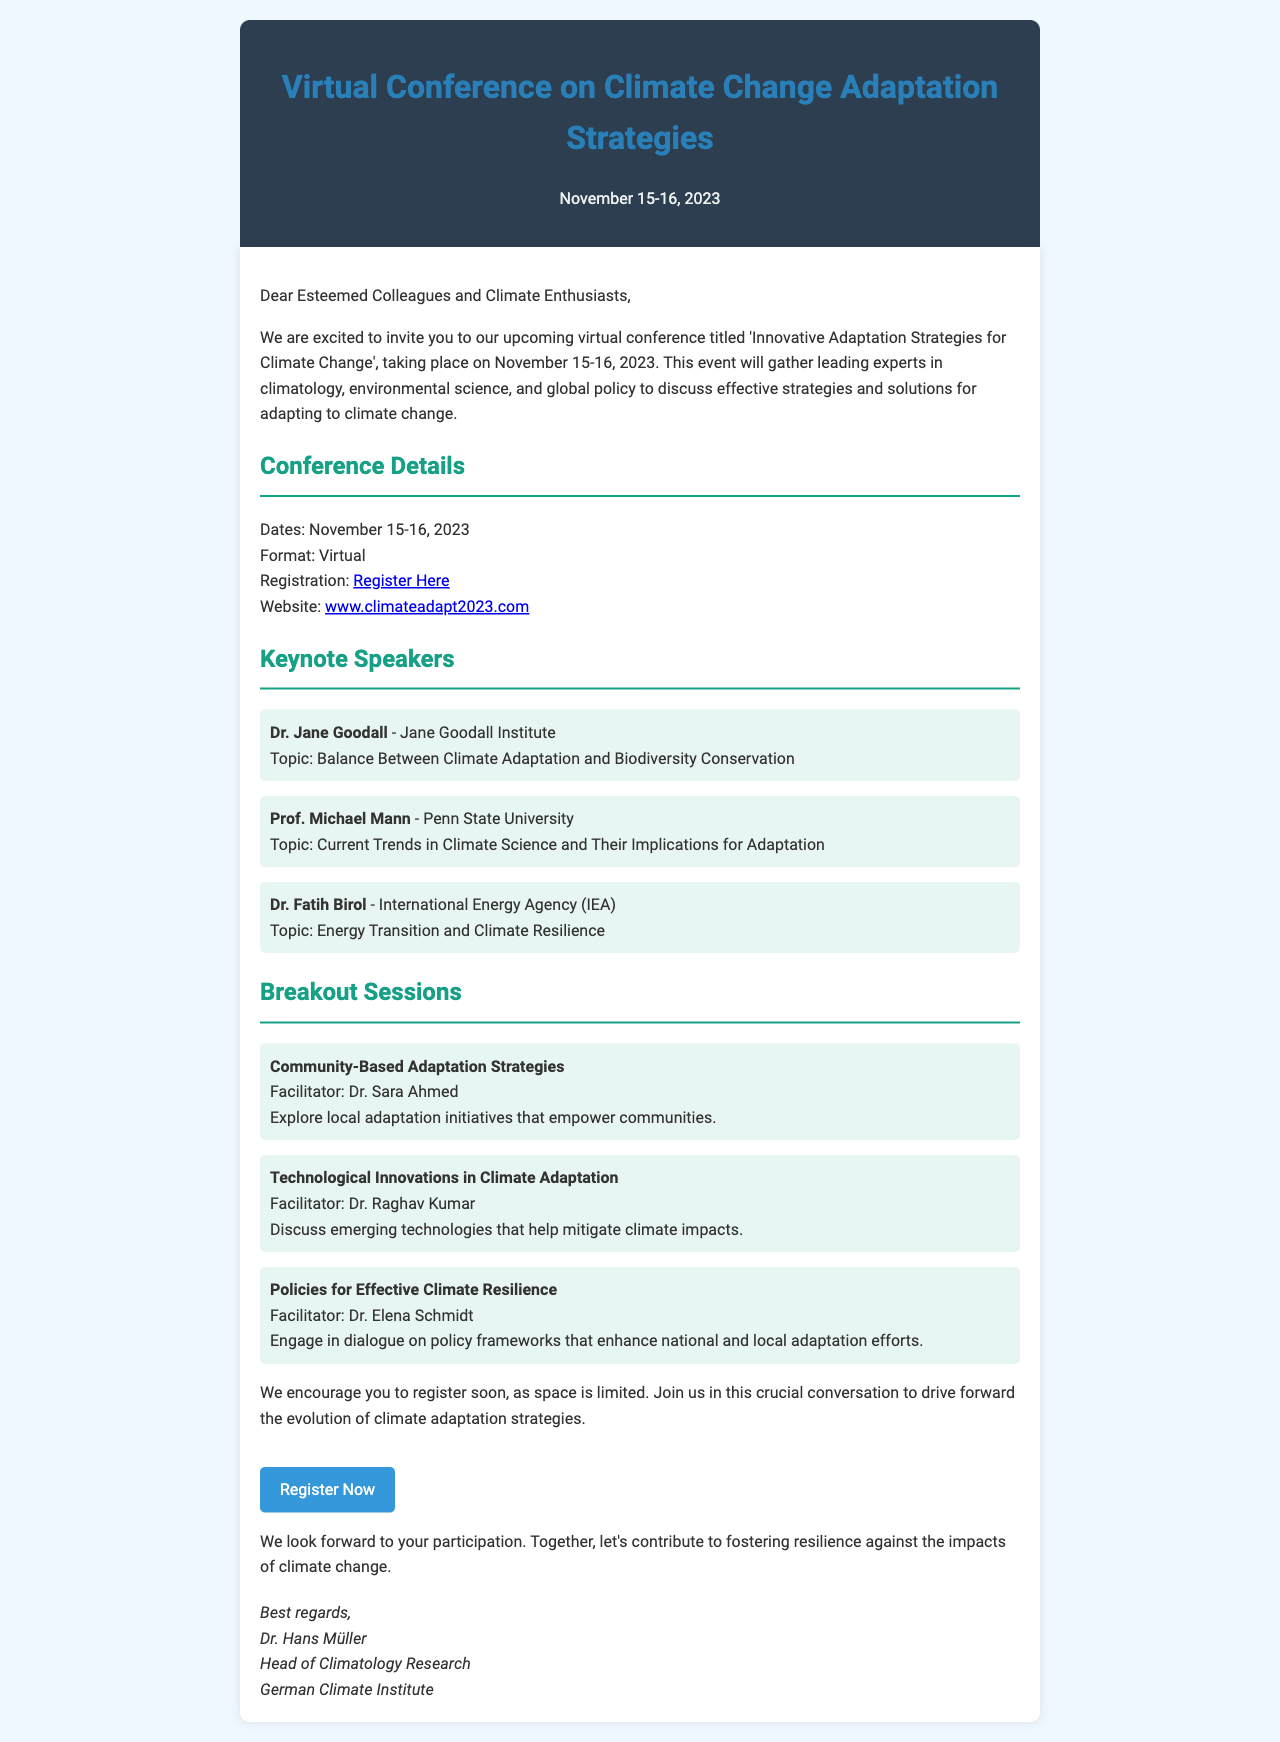what are the dates of the conference? The dates of the conference are specified in the document as November 15-16, 2023.
Answer: November 15-16, 2023 who is the facilitator for the breakout session on "Community-Based Adaptation Strategies"? The facilitator for this breakout session is mentioned as Dr. Sara Ahmed in the session details.
Answer: Dr. Sara Ahmed how many keynote speakers are listed in the document? The document lists three keynote speakers, providing their names and affiliations.
Answer: Three what is the topic of Dr. Jane Goodall's keynote speech? The document specifies her topic as "Balance Between Climate Adaptation and Biodiversity Conservation".
Answer: Balance Between Climate Adaptation and Biodiversity Conservation which organization does Prof. Michael Mann represent? The document states that Prof. Michael Mann is from Penn State University, which is his affiliated organization.
Answer: Penn State University what type of event is this conference? The event is described as a virtual conference in the document.
Answer: Virtual what is the call to action in the document? The call to action encourages readers to register for the conference, as mentioned in the concluding paragraphs.
Answer: Register Now 